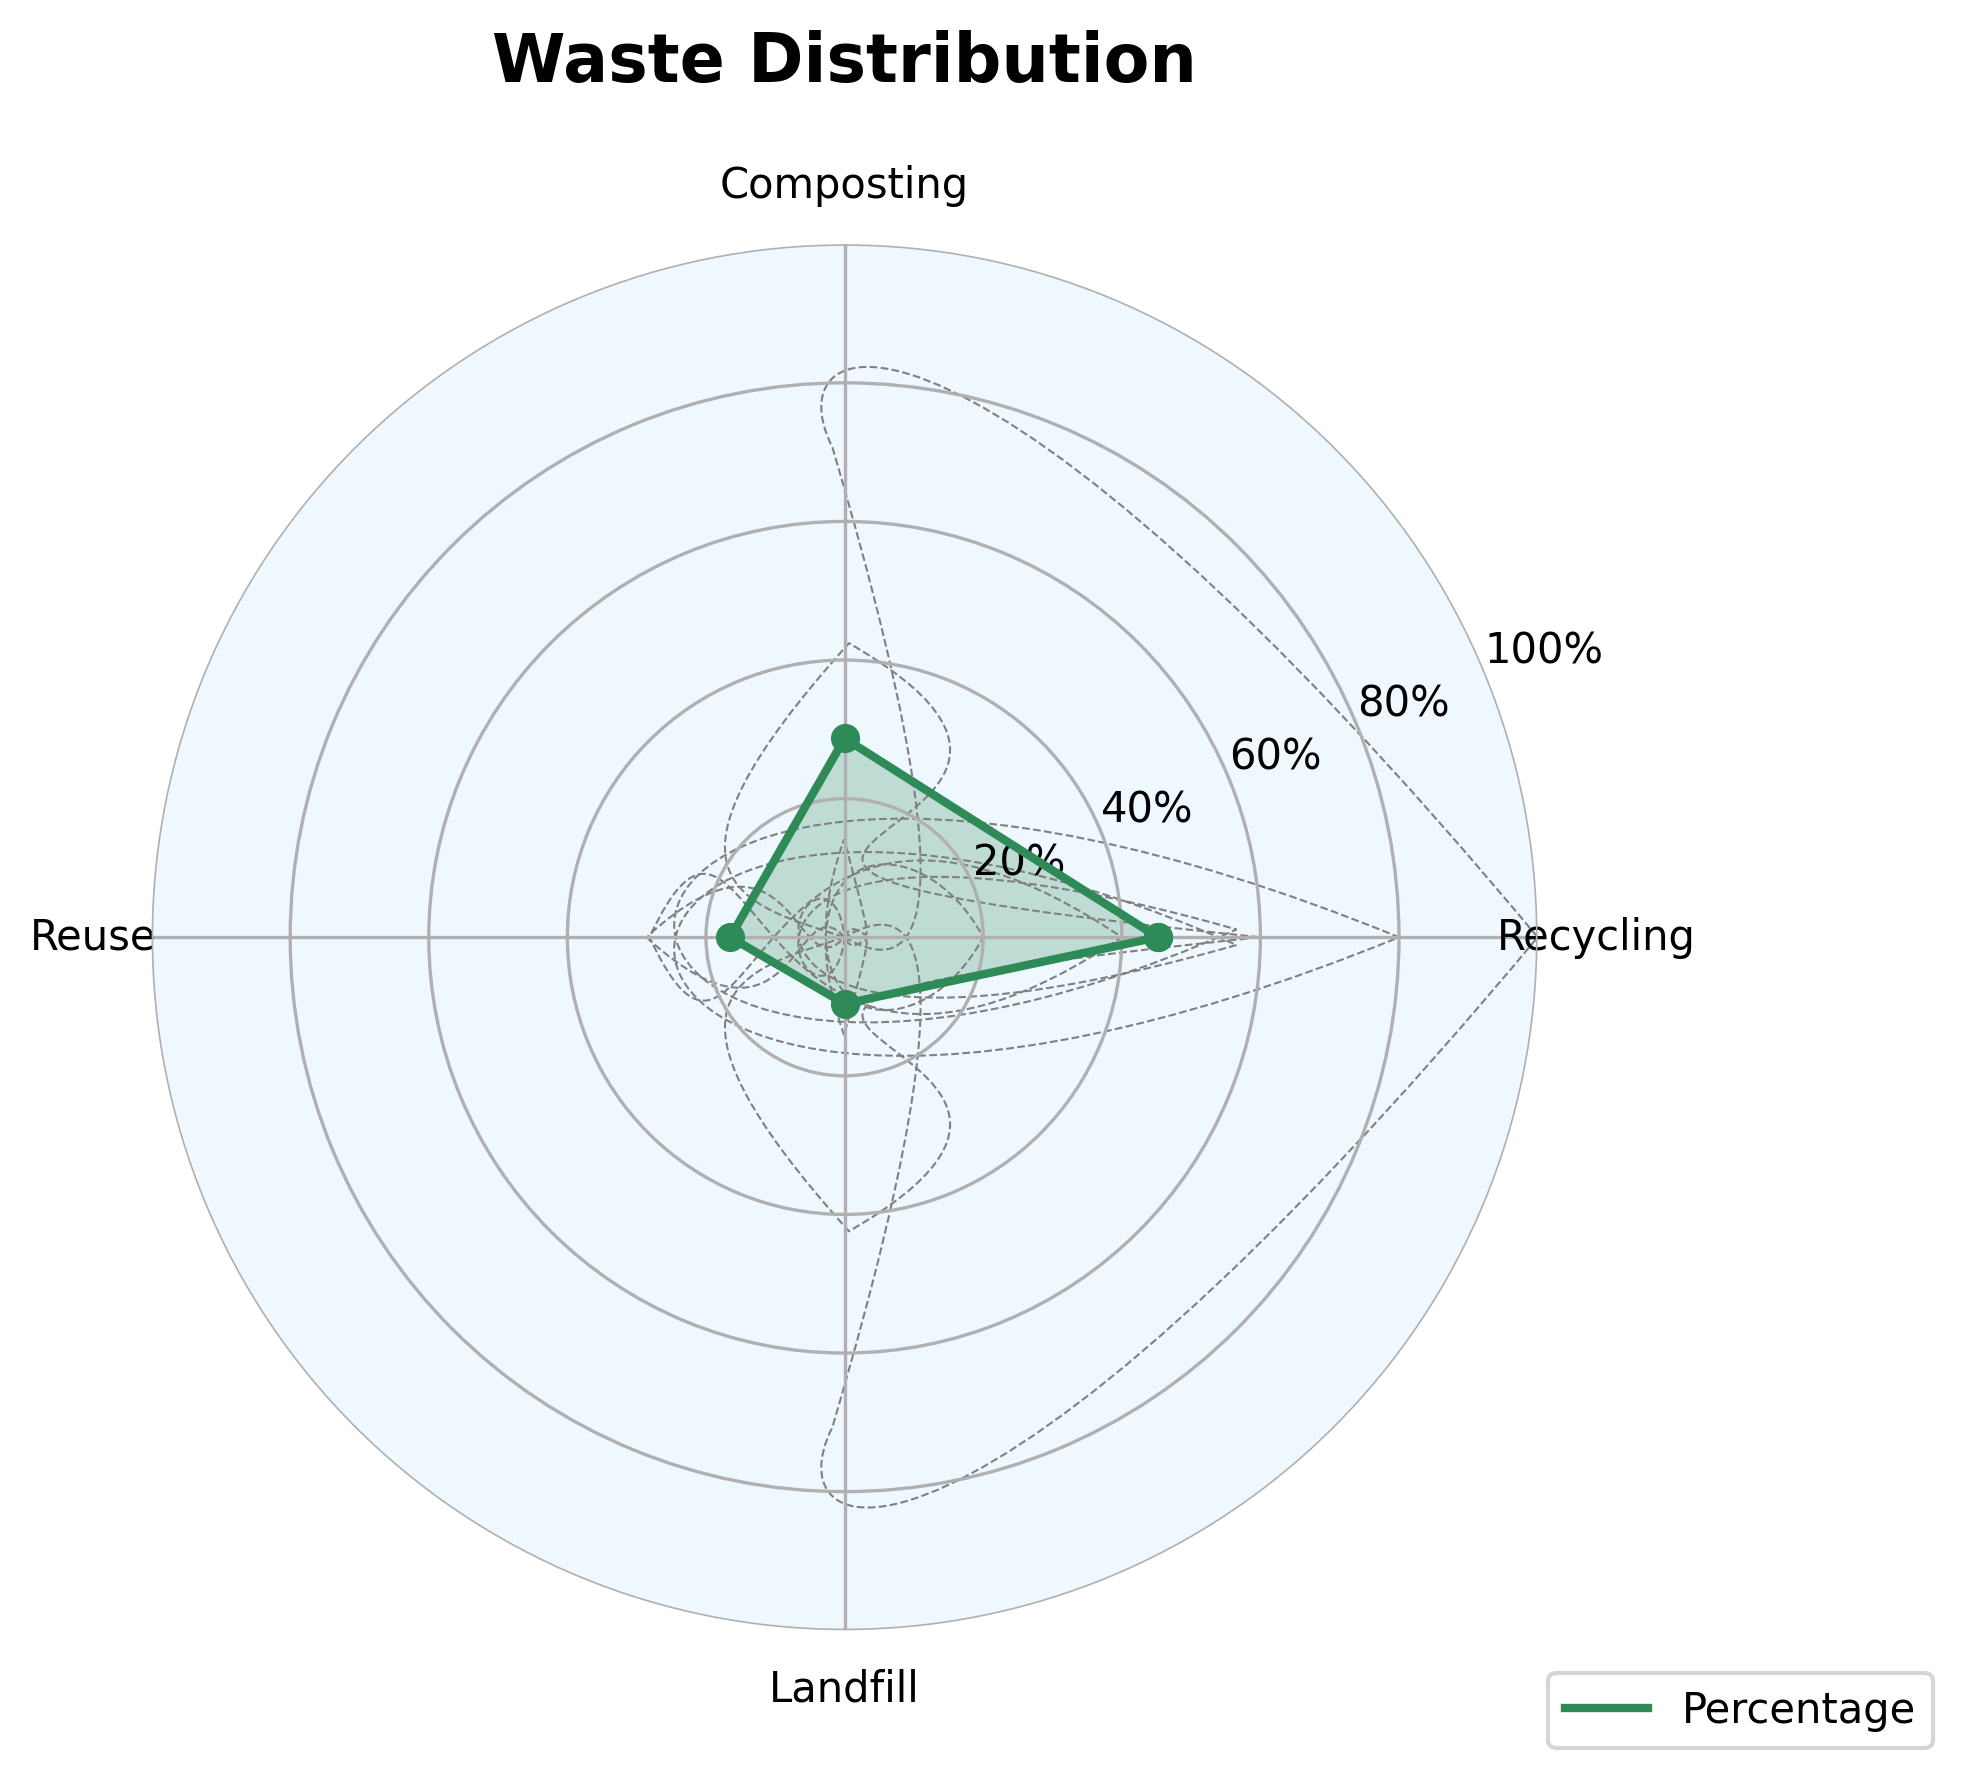Which category has the highest percentage of waste diverted from landfills? By observing the plot, we see that Recycling has the highest position on the gauge, indicating the highest percentage.
Answer: Recycling What is the title of the figure? The title is located at the top center of the figure in bold font.
Answer: Waste Distribution How many categories are presented in the figure? Count the number of labels around the plot on the x-axis.
Answer: 4 What's the combined percentage of waste diverted from landfills by composting and reuse? Look at the percentages for Composting and Reuse, sum them: 28.7 + 16.5.
Answer: 45.2% Which category has the lowest percentage of waste diverted from landfills? By observing the plot, we see that Landfill has the lowest position on the gauge, indicating the lowest percentage.
Answer: Landfill Is the percentage of waste diverted by composting greater than by reuse? Compare the percentages for Composting and Reuse: 28.7 vs 16.5.
Answer: Yes What is the percentage of waste diverted from landfills by reuse? Find the label "Reuse" on the gauge and read its corresponding percentage.
Answer: 16.5% Is the total percentage of waste diverted from landfills by Recycling, Composting, and Reuse more than 90%? Calculate the sum: 45.2 + 28.7 + 16.5 = 90.4%, which is more than 90%.
Answer: Yes What is the range of percentages displayed on the y-axis? The minimum value on the y-axis is 0, and the maximum is 100.
Answer: 0-100% How does the percentage of waste diverted from landfills by recycling compare to composting? Recycling has 45.2% and Composting has 28.7%. 45.2% is greater than 28.7%.
Answer: Recycling > Composting 